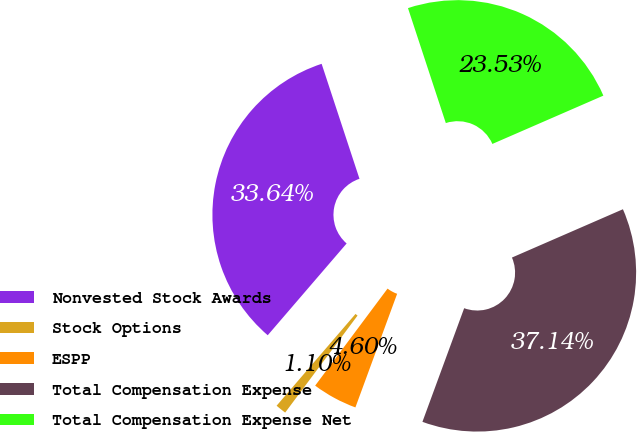Convert chart. <chart><loc_0><loc_0><loc_500><loc_500><pie_chart><fcel>Nonvested Stock Awards<fcel>Stock Options<fcel>ESPP<fcel>Total Compensation Expense<fcel>Total Compensation Expense Net<nl><fcel>33.64%<fcel>1.1%<fcel>4.6%<fcel>37.14%<fcel>23.53%<nl></chart> 